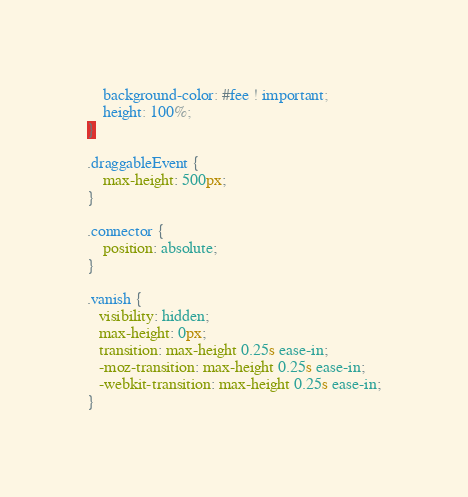<code> <loc_0><loc_0><loc_500><loc_500><_CSS_>    background-color: #fee ! important;
    height: 100%;
}

.draggableEvent {
    max-height: 500px;
}

.connector {
    position: absolute;
}

.vanish {
   visibility: hidden;
   max-height: 0px;
   transition: max-height 0.25s ease-in;
   -moz-transition: max-height 0.25s ease-in;
   -webkit-transition: max-height 0.25s ease-in;
}</code> 